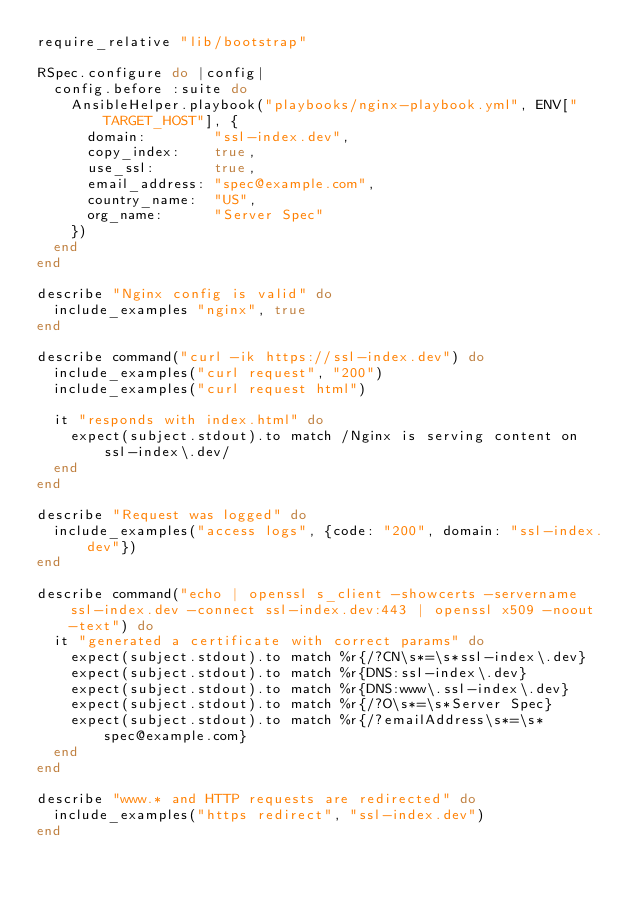<code> <loc_0><loc_0><loc_500><loc_500><_Ruby_>require_relative "lib/bootstrap"

RSpec.configure do |config|
  config.before :suite do
    AnsibleHelper.playbook("playbooks/nginx-playbook.yml", ENV["TARGET_HOST"], {
      domain:        "ssl-index.dev",
      copy_index:    true,
      use_ssl:       true,
      email_address: "spec@example.com",
      country_name:  "US",
      org_name:      "Server Spec"
    })
  end
end

describe "Nginx config is valid" do
  include_examples "nginx", true
end

describe command("curl -ik https://ssl-index.dev") do
  include_examples("curl request", "200")
  include_examples("curl request html")

  it "responds with index.html" do
    expect(subject.stdout).to match /Nginx is serving content on ssl-index\.dev/
  end
end

describe "Request was logged" do
  include_examples("access logs", {code: "200", domain: "ssl-index.dev"})
end

describe command("echo | openssl s_client -showcerts -servername ssl-index.dev -connect ssl-index.dev:443 | openssl x509 -noout -text") do
  it "generated a certificate with correct params" do
    expect(subject.stdout).to match %r{/?CN\s*=\s*ssl-index\.dev}
    expect(subject.stdout).to match %r{DNS:ssl-index\.dev}
    expect(subject.stdout).to match %r{DNS:www\.ssl-index\.dev}
    expect(subject.stdout).to match %r{/?O\s*=\s*Server Spec}
    expect(subject.stdout).to match %r{/?emailAddress\s*=\s*spec@example.com}
  end
end

describe "www.* and HTTP requests are redirected" do
  include_examples("https redirect", "ssl-index.dev")
end
</code> 